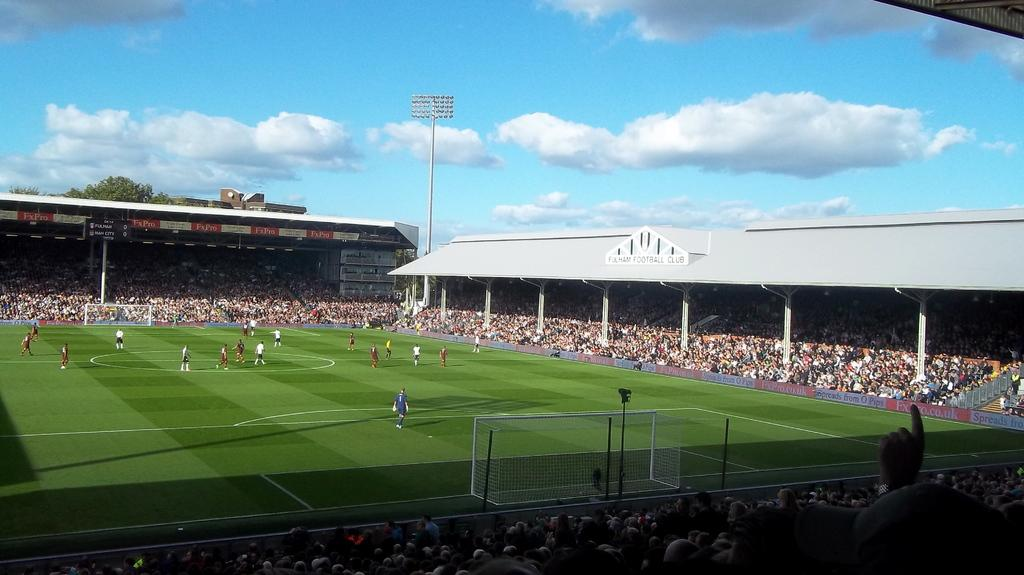What type of venue is depicted in the image? There is a football stadium in the image. What activity is taking place on the field? Players are playing on the grass field. Can you describe the people in the image who are not playing? There is an audience in the image. What can be seen in the sky above the stadium? The sky is visible in the image, and clouds are present. How much salt is sprinkled on the grass field in the image? There is no salt present in the image; it is a football stadium with players on a grass field. What type of park is visible in the image? There is no park present in the image; it is a football stadium with players on a grass field. 